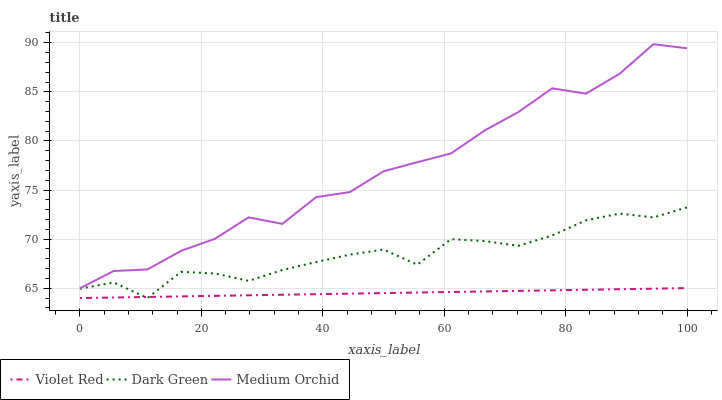Does Violet Red have the minimum area under the curve?
Answer yes or no. Yes. Does Medium Orchid have the maximum area under the curve?
Answer yes or no. Yes. Does Dark Green have the minimum area under the curve?
Answer yes or no. No. Does Dark Green have the maximum area under the curve?
Answer yes or no. No. Is Violet Red the smoothest?
Answer yes or no. Yes. Is Medium Orchid the roughest?
Answer yes or no. Yes. Is Dark Green the smoothest?
Answer yes or no. No. Is Dark Green the roughest?
Answer yes or no. No. Does Violet Red have the lowest value?
Answer yes or no. Yes. Does Medium Orchid have the lowest value?
Answer yes or no. No. Does Medium Orchid have the highest value?
Answer yes or no. Yes. Does Dark Green have the highest value?
Answer yes or no. No. Is Dark Green less than Medium Orchid?
Answer yes or no. Yes. Is Medium Orchid greater than Dark Green?
Answer yes or no. Yes. Does Dark Green intersect Violet Red?
Answer yes or no. Yes. Is Dark Green less than Violet Red?
Answer yes or no. No. Is Dark Green greater than Violet Red?
Answer yes or no. No. Does Dark Green intersect Medium Orchid?
Answer yes or no. No. 